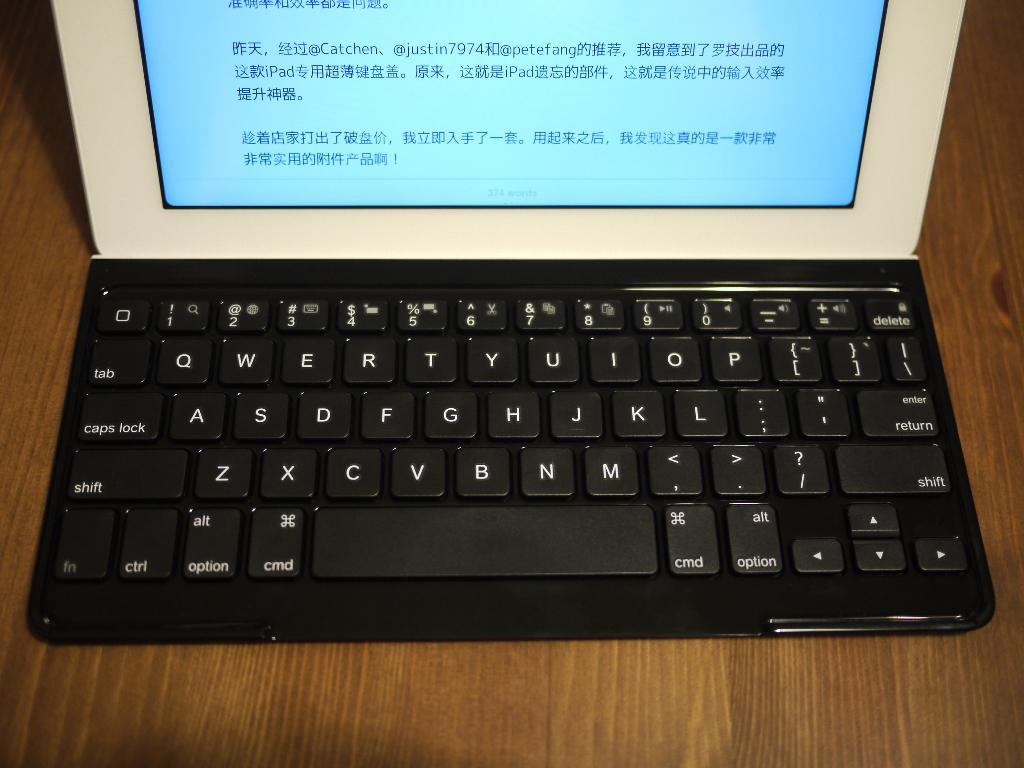<image>
Render a clear and concise summary of the photo. A laptop with chinese characters on the screen relating to an iPad. 